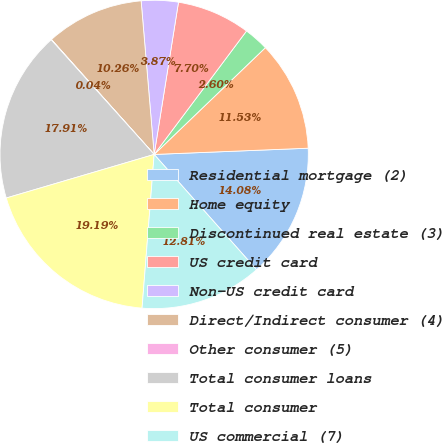<chart> <loc_0><loc_0><loc_500><loc_500><pie_chart><fcel>Residential mortgage (2)<fcel>Home equity<fcel>Discontinued real estate (3)<fcel>US credit card<fcel>Non-US credit card<fcel>Direct/Indirect consumer (4)<fcel>Other consumer (5)<fcel>Total consumer loans<fcel>Total consumer<fcel>US commercial (7)<nl><fcel>14.08%<fcel>11.53%<fcel>2.6%<fcel>7.7%<fcel>3.87%<fcel>10.26%<fcel>0.04%<fcel>17.91%<fcel>19.19%<fcel>12.81%<nl></chart> 